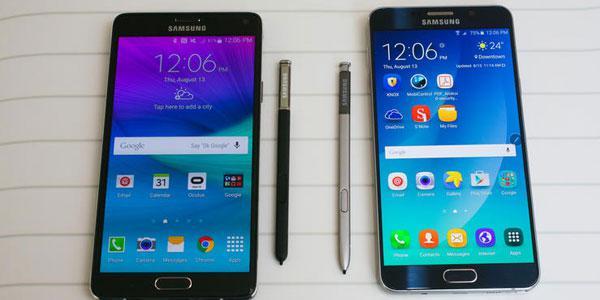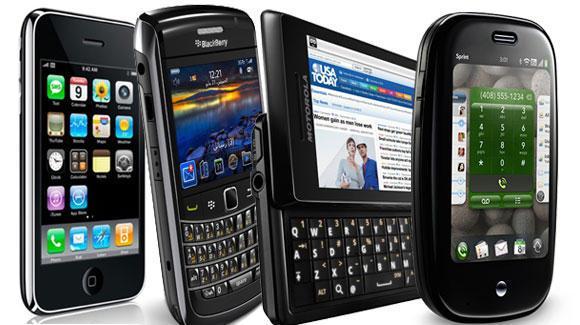The first image is the image on the left, the second image is the image on the right. Given the left and right images, does the statement "The left image contains no more than two cell phones." hold true? Answer yes or no. Yes. 